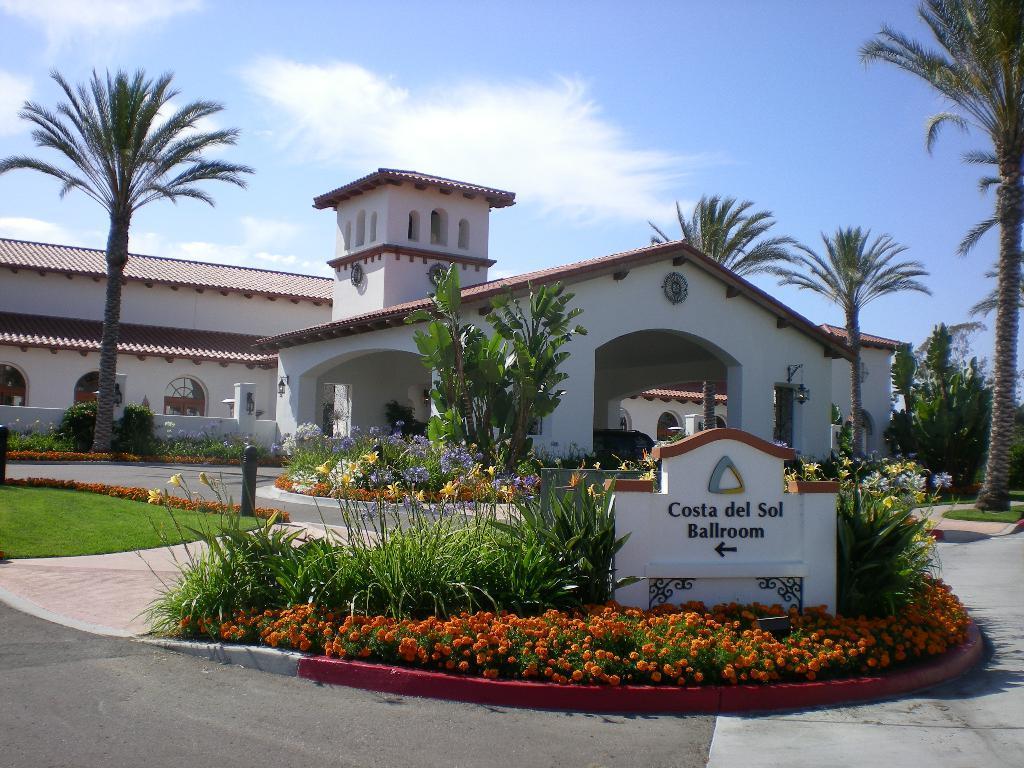In one or two sentences, can you explain what this image depicts? In this picture we can see a name on the wall, flowers, plants, trees, path, grass, building with windows and some objects and in the background we can see the sky with clouds. 